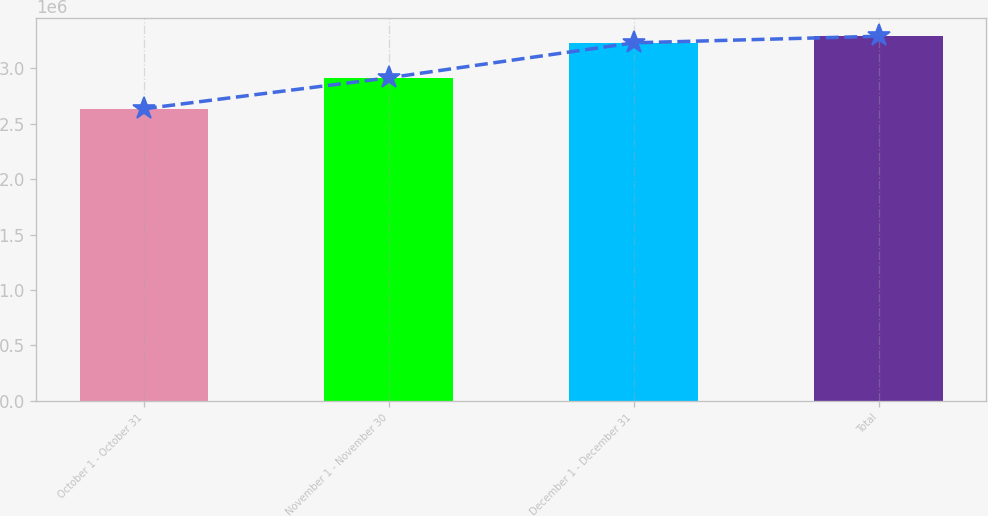<chart> <loc_0><loc_0><loc_500><loc_500><bar_chart><fcel>October 1 - October 31<fcel>November 1 - November 30<fcel>December 1 - December 31<fcel>Total<nl><fcel>2.63618e+06<fcel>2.91578e+06<fcel>3.23148e+06<fcel>3.29101e+06<nl></chart> 